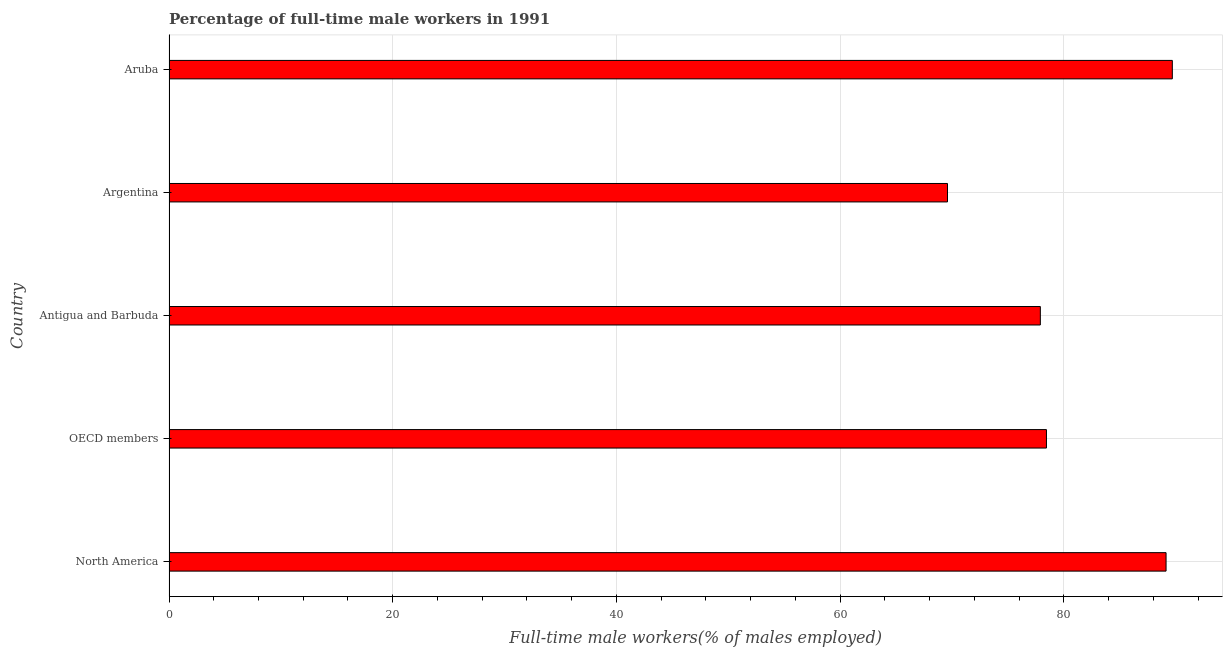Does the graph contain grids?
Your answer should be compact. Yes. What is the title of the graph?
Provide a succinct answer. Percentage of full-time male workers in 1991. What is the label or title of the X-axis?
Your answer should be very brief. Full-time male workers(% of males employed). What is the percentage of full-time male workers in Antigua and Barbuda?
Your response must be concise. 77.9. Across all countries, what is the maximum percentage of full-time male workers?
Ensure brevity in your answer.  89.7. Across all countries, what is the minimum percentage of full-time male workers?
Provide a succinct answer. 69.6. In which country was the percentage of full-time male workers maximum?
Ensure brevity in your answer.  Aruba. In which country was the percentage of full-time male workers minimum?
Give a very brief answer. Argentina. What is the sum of the percentage of full-time male workers?
Offer a very short reply. 404.79. What is the difference between the percentage of full-time male workers in Antigua and Barbuda and OECD members?
Ensure brevity in your answer.  -0.55. What is the average percentage of full-time male workers per country?
Make the answer very short. 80.96. What is the median percentage of full-time male workers?
Your answer should be very brief. 78.45. In how many countries, is the percentage of full-time male workers greater than 80 %?
Your answer should be compact. 2. What is the ratio of the percentage of full-time male workers in Aruba to that in OECD members?
Give a very brief answer. 1.14. Is the percentage of full-time male workers in Argentina less than that in OECD members?
Provide a succinct answer. Yes. Is the difference between the percentage of full-time male workers in Argentina and Aruba greater than the difference between any two countries?
Keep it short and to the point. Yes. What is the difference between the highest and the second highest percentage of full-time male workers?
Your answer should be very brief. 0.56. Is the sum of the percentage of full-time male workers in North America and OECD members greater than the maximum percentage of full-time male workers across all countries?
Your answer should be very brief. Yes. What is the difference between the highest and the lowest percentage of full-time male workers?
Your answer should be very brief. 20.1. In how many countries, is the percentage of full-time male workers greater than the average percentage of full-time male workers taken over all countries?
Your answer should be compact. 2. How many countries are there in the graph?
Ensure brevity in your answer.  5. Are the values on the major ticks of X-axis written in scientific E-notation?
Keep it short and to the point. No. What is the Full-time male workers(% of males employed) of North America?
Your response must be concise. 89.14. What is the Full-time male workers(% of males employed) in OECD members?
Offer a very short reply. 78.45. What is the Full-time male workers(% of males employed) of Antigua and Barbuda?
Provide a succinct answer. 77.9. What is the Full-time male workers(% of males employed) of Argentina?
Make the answer very short. 69.6. What is the Full-time male workers(% of males employed) in Aruba?
Make the answer very short. 89.7. What is the difference between the Full-time male workers(% of males employed) in North America and OECD members?
Your answer should be compact. 10.69. What is the difference between the Full-time male workers(% of males employed) in North America and Antigua and Barbuda?
Ensure brevity in your answer.  11.24. What is the difference between the Full-time male workers(% of males employed) in North America and Argentina?
Provide a succinct answer. 19.54. What is the difference between the Full-time male workers(% of males employed) in North America and Aruba?
Keep it short and to the point. -0.56. What is the difference between the Full-time male workers(% of males employed) in OECD members and Antigua and Barbuda?
Your answer should be compact. 0.55. What is the difference between the Full-time male workers(% of males employed) in OECD members and Argentina?
Your answer should be compact. 8.85. What is the difference between the Full-time male workers(% of males employed) in OECD members and Aruba?
Keep it short and to the point. -11.25. What is the difference between the Full-time male workers(% of males employed) in Antigua and Barbuda and Argentina?
Make the answer very short. 8.3. What is the difference between the Full-time male workers(% of males employed) in Argentina and Aruba?
Offer a very short reply. -20.1. What is the ratio of the Full-time male workers(% of males employed) in North America to that in OECD members?
Ensure brevity in your answer.  1.14. What is the ratio of the Full-time male workers(% of males employed) in North America to that in Antigua and Barbuda?
Your response must be concise. 1.14. What is the ratio of the Full-time male workers(% of males employed) in North America to that in Argentina?
Offer a very short reply. 1.28. What is the ratio of the Full-time male workers(% of males employed) in North America to that in Aruba?
Offer a terse response. 0.99. What is the ratio of the Full-time male workers(% of males employed) in OECD members to that in Argentina?
Provide a short and direct response. 1.13. What is the ratio of the Full-time male workers(% of males employed) in OECD members to that in Aruba?
Make the answer very short. 0.88. What is the ratio of the Full-time male workers(% of males employed) in Antigua and Barbuda to that in Argentina?
Your answer should be very brief. 1.12. What is the ratio of the Full-time male workers(% of males employed) in Antigua and Barbuda to that in Aruba?
Offer a terse response. 0.87. What is the ratio of the Full-time male workers(% of males employed) in Argentina to that in Aruba?
Keep it short and to the point. 0.78. 